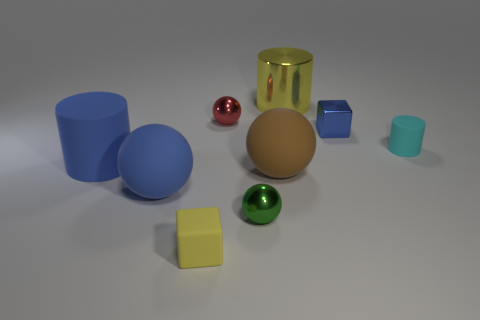What is the size of the red object that is the same shape as the tiny green object?
Make the answer very short. Small. Are there any other things that are the same shape as the small blue thing?
Provide a succinct answer. Yes. What size is the yellow matte thing?
Give a very brief answer. Small. Are there fewer big blue matte cylinders behind the red sphere than small yellow shiny balls?
Your response must be concise. No. Do the red sphere and the yellow shiny thing have the same size?
Provide a succinct answer. No. Is there any other thing that is the same size as the red thing?
Provide a succinct answer. Yes. What is the color of the tiny thing that is the same material as the small cylinder?
Keep it short and to the point. Yellow. Are there fewer tiny blue metallic objects that are behind the tiny red object than yellow things right of the tiny yellow block?
Make the answer very short. Yes. What number of small cylinders have the same color as the tiny rubber block?
Provide a succinct answer. 0. There is a thing that is the same color as the small matte block; what is its material?
Your response must be concise. Metal. 